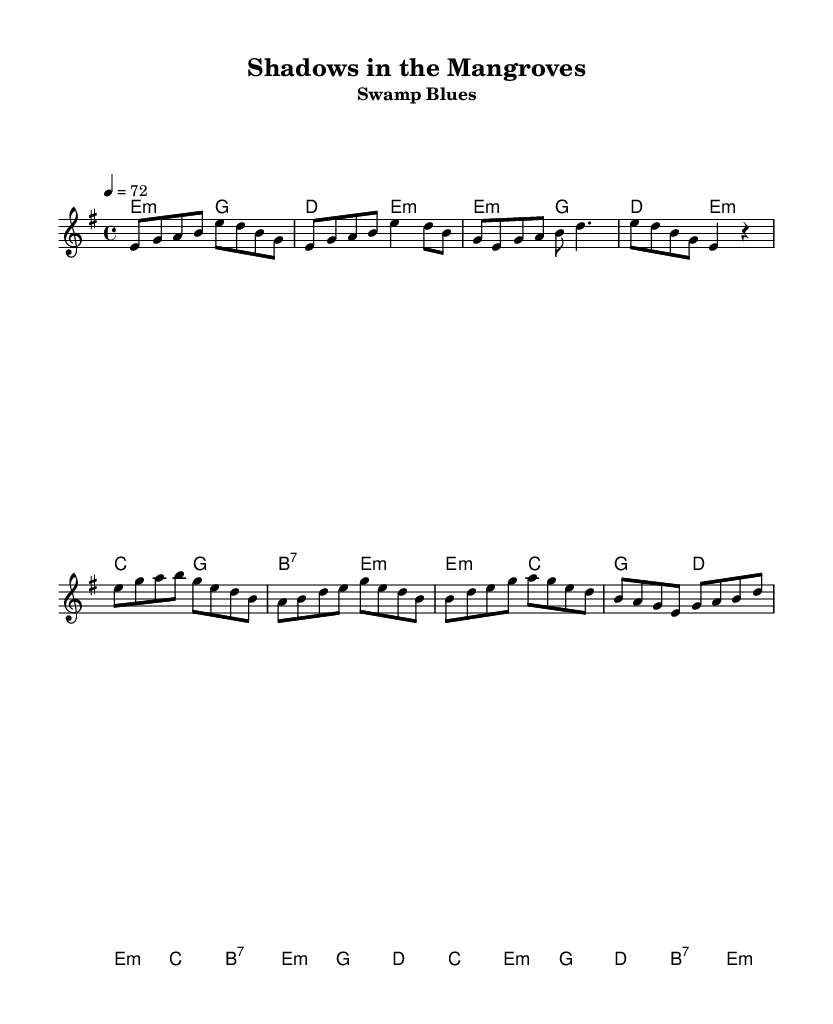What is the key signature of this music? The key signature is E minor, indicated by a single sharp (F#). It is found at the beginning of the staff.
Answer: E minor What is the time signature of this music? The time signature is 4/4, which indicates four beats per measure. This is visible at the beginning of the sheet music.
Answer: 4/4 What is the tempo marking for this piece? The tempo marking is 72 beats per minute, explicitly stated in the tempo section of the score.
Answer: 72 How many measures are in the verse section? The verse section consists of three measures, as seen when analyzing the melody line dedicated to the verse.
Answer: three What is the primary theme expressed in the lyrics of the chorus? The primary theme of the chorus focuses on covert operations and hidden danger, which can be deduced by examining the lyrical content questioning the unseen threats in tropical settings.
Answer: covert ops What chords are used in the chorus? The chorus uses the chords E minor, C major, G major, D major, and B7. This is determined by analyzing the chord symbols listed alongside the melody line in the chorus section.
Answer: E minor, C, G, D, B7 What type of rhythm predominates in this music? The predominant rhythm in this music features eighth and quarter notes, which is typical for blues, giving it a swing feel. This can be seen throughout the melody.
Answer: eighth and quarter notes 